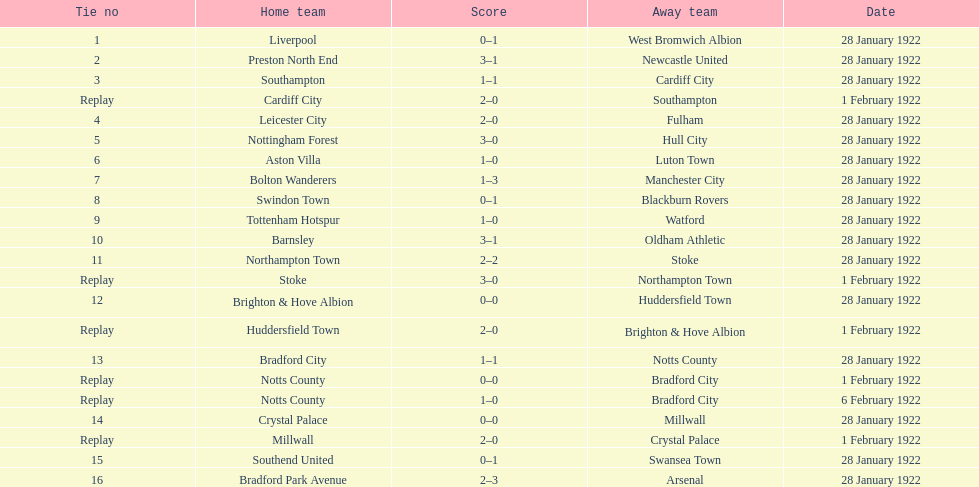Can you parse all the data within this table? {'header': ['Tie no', 'Home team', 'Score', 'Away team', 'Date'], 'rows': [['1', 'Liverpool', '0–1', 'West Bromwich Albion', '28 January 1922'], ['2', 'Preston North End', '3–1', 'Newcastle United', '28 January 1922'], ['3', 'Southampton', '1–1', 'Cardiff City', '28 January 1922'], ['Replay', 'Cardiff City', '2–0', 'Southampton', '1 February 1922'], ['4', 'Leicester City', '2–0', 'Fulham', '28 January 1922'], ['5', 'Nottingham Forest', '3–0', 'Hull City', '28 January 1922'], ['6', 'Aston Villa', '1–0', 'Luton Town', '28 January 1922'], ['7', 'Bolton Wanderers', '1–3', 'Manchester City', '28 January 1922'], ['8', 'Swindon Town', '0–1', 'Blackburn Rovers', '28 January 1922'], ['9', 'Tottenham Hotspur', '1–0', 'Watford', '28 January 1922'], ['10', 'Barnsley', '3–1', 'Oldham Athletic', '28 January 1922'], ['11', 'Northampton Town', '2–2', 'Stoke', '28 January 1922'], ['Replay', 'Stoke', '3–0', 'Northampton Town', '1 February 1922'], ['12', 'Brighton & Hove Albion', '0–0', 'Huddersfield Town', '28 January 1922'], ['Replay', 'Huddersfield Town', '2–0', 'Brighton & Hove Albion', '1 February 1922'], ['13', 'Bradford City', '1–1', 'Notts County', '28 January 1922'], ['Replay', 'Notts County', '0–0', 'Bradford City', '1 February 1922'], ['Replay', 'Notts County', '1–0', 'Bradford City', '6 February 1922'], ['14', 'Crystal Palace', '0–0', 'Millwall', '28 January 1922'], ['Replay', 'Millwall', '2–0', 'Crystal Palace', '1 February 1922'], ['15', 'Southend United', '0–1', 'Swansea Town', '28 January 1922'], ['16', 'Bradford Park Avenue', '2–3', 'Arsenal', '28 January 1922']]} How many games witnessed a scoring of four total points or higher? 5. 